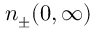Convert formula to latex. <formula><loc_0><loc_0><loc_500><loc_500>n _ { \pm } ( 0 , \infty )</formula> 